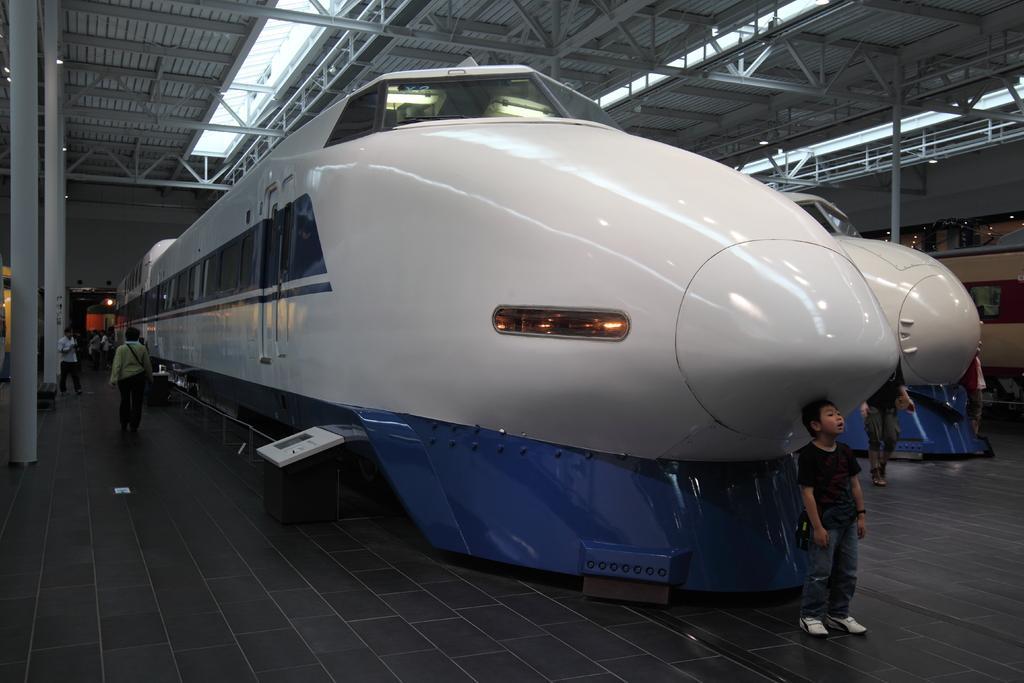Describe this image in one or two sentences. In this picture, it seems to be a bullet train in the center of the image and there is another one on the right side of the image, there is roof at the top side of the image and there are poles on the left side of the image and there are people in the image. 